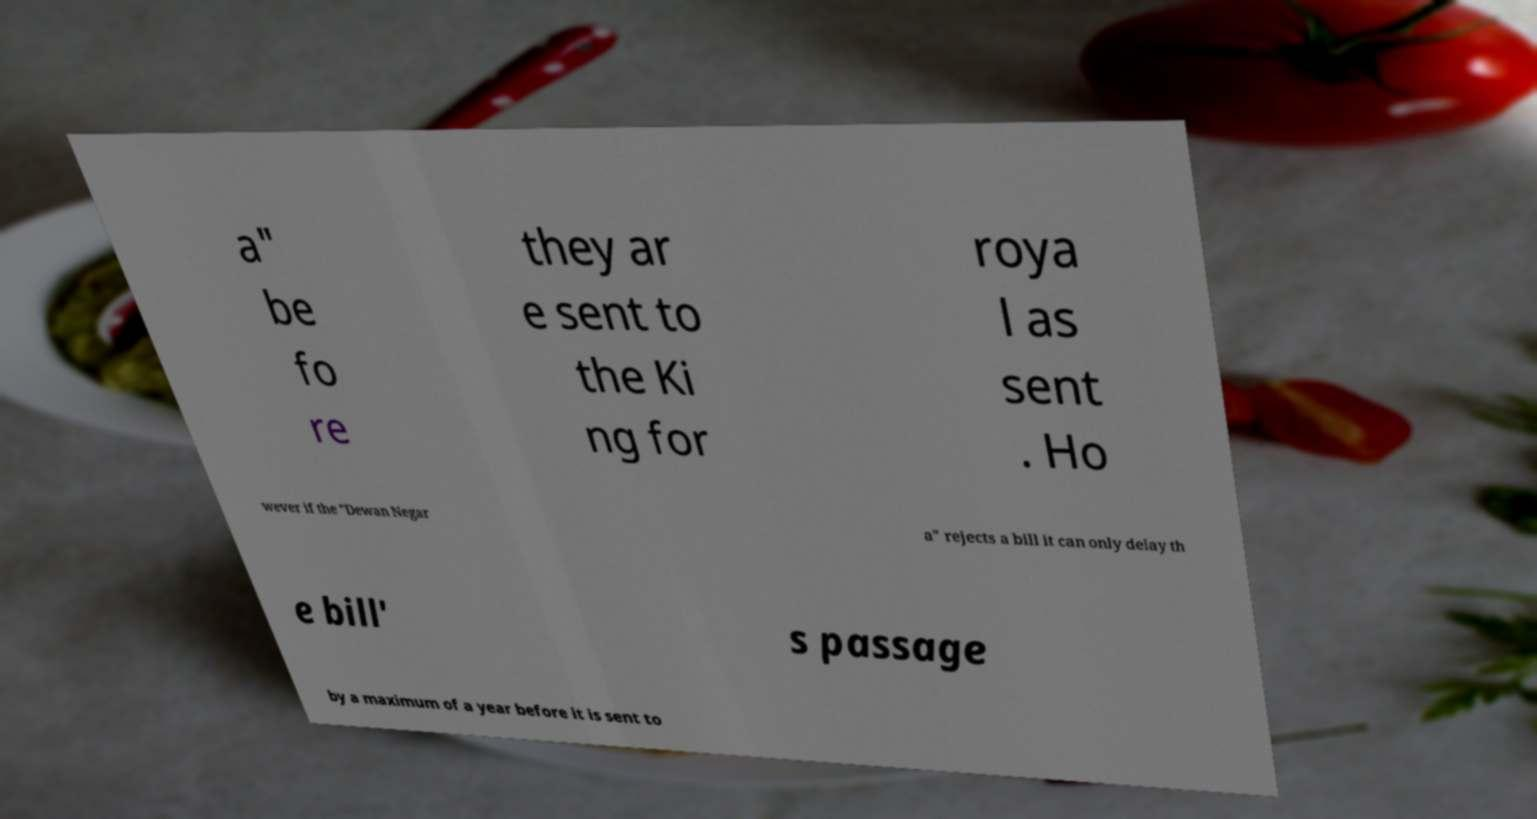I need the written content from this picture converted into text. Can you do that? a" be fo re they ar e sent to the Ki ng for roya l as sent . Ho wever if the "Dewan Negar a" rejects a bill it can only delay th e bill' s passage by a maximum of a year before it is sent to 